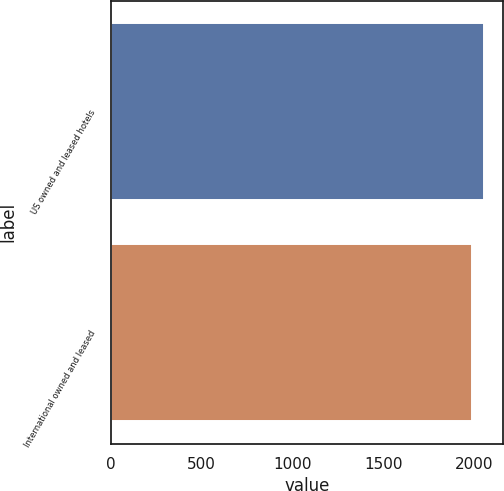Convert chart to OTSL. <chart><loc_0><loc_0><loc_500><loc_500><bar_chart><fcel>US owned and leased hotels<fcel>International owned and leased<nl><fcel>2058<fcel>1988<nl></chart> 